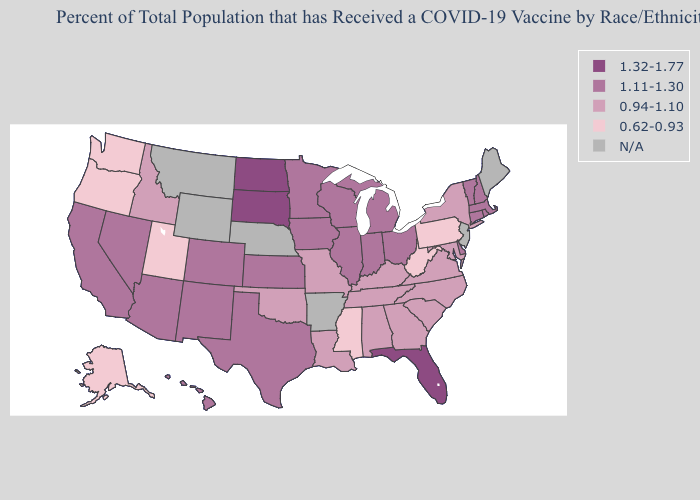Which states have the highest value in the USA?
Write a very short answer. Florida, North Dakota, South Dakota. Does Hawaii have the lowest value in the USA?
Write a very short answer. No. What is the highest value in the West ?
Write a very short answer. 1.11-1.30. What is the value of South Carolina?
Short answer required. 0.94-1.10. What is the value of New York?
Short answer required. 0.94-1.10. Among the states that border Missouri , does Illinois have the highest value?
Answer briefly. Yes. What is the lowest value in the USA?
Quick response, please. 0.62-0.93. Name the states that have a value in the range 1.32-1.77?
Write a very short answer. Florida, North Dakota, South Dakota. Which states hav the highest value in the South?
Be succinct. Florida. What is the value of Maryland?
Answer briefly. 0.94-1.10. Does the map have missing data?
Give a very brief answer. Yes. Among the states that border Massachusetts , does New York have the highest value?
Give a very brief answer. No. Does the map have missing data?
Be succinct. Yes. Name the states that have a value in the range 1.11-1.30?
Quick response, please. Arizona, California, Colorado, Connecticut, Delaware, Hawaii, Illinois, Indiana, Iowa, Kansas, Massachusetts, Michigan, Minnesota, Nevada, New Hampshire, New Mexico, Ohio, Rhode Island, Texas, Vermont, Wisconsin. 